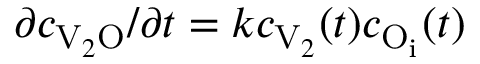Convert formula to latex. <formula><loc_0><loc_0><loc_500><loc_500>\partial c _ { V _ { 2 } O } / \partial t = k c _ { V _ { 2 } } ( t ) c _ { O _ { i } } ( t )</formula> 